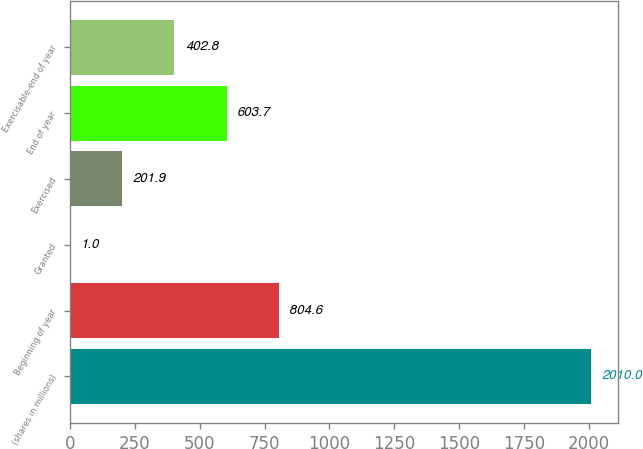Convert chart to OTSL. <chart><loc_0><loc_0><loc_500><loc_500><bar_chart><fcel>(shares in millions)<fcel>Beginning of year<fcel>Granted<fcel>Exercised<fcel>End of year<fcel>Exercisable-end of year<nl><fcel>2010<fcel>804.6<fcel>1<fcel>201.9<fcel>603.7<fcel>402.8<nl></chart> 